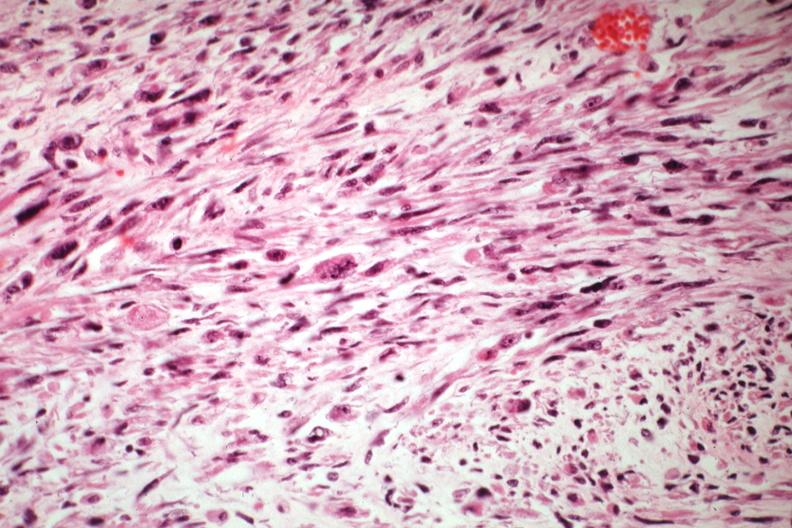s adrenal of premature 30 week gestation gram infant lesion present?
Answer the question using a single word or phrase. No 